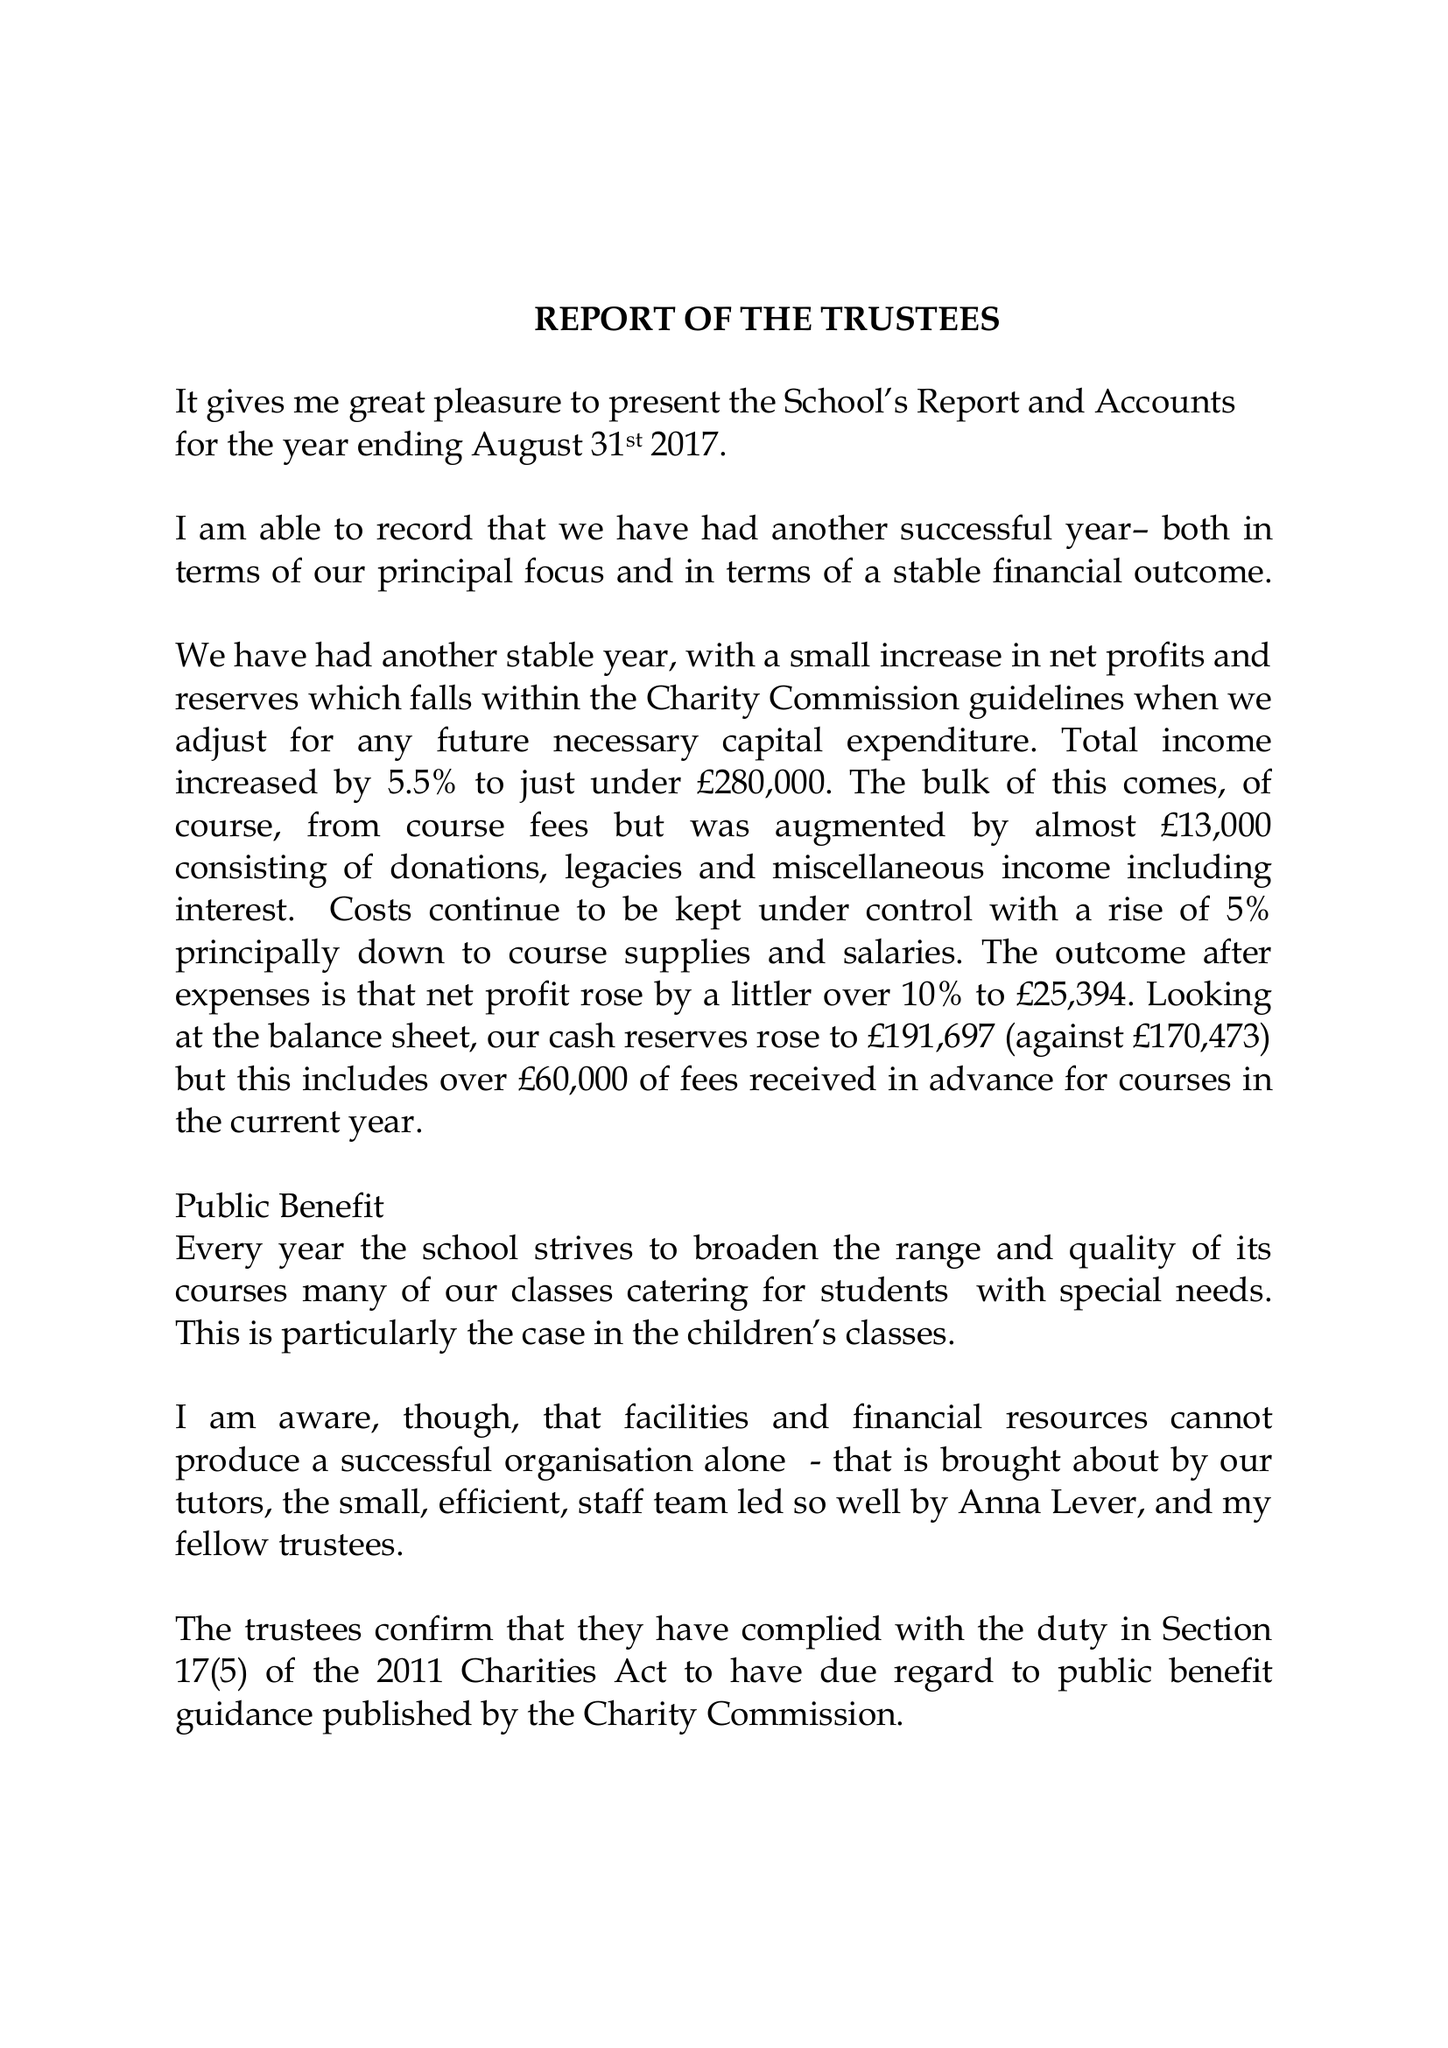What is the value for the charity_number?
Answer the question using a single word or phrase. 273652 